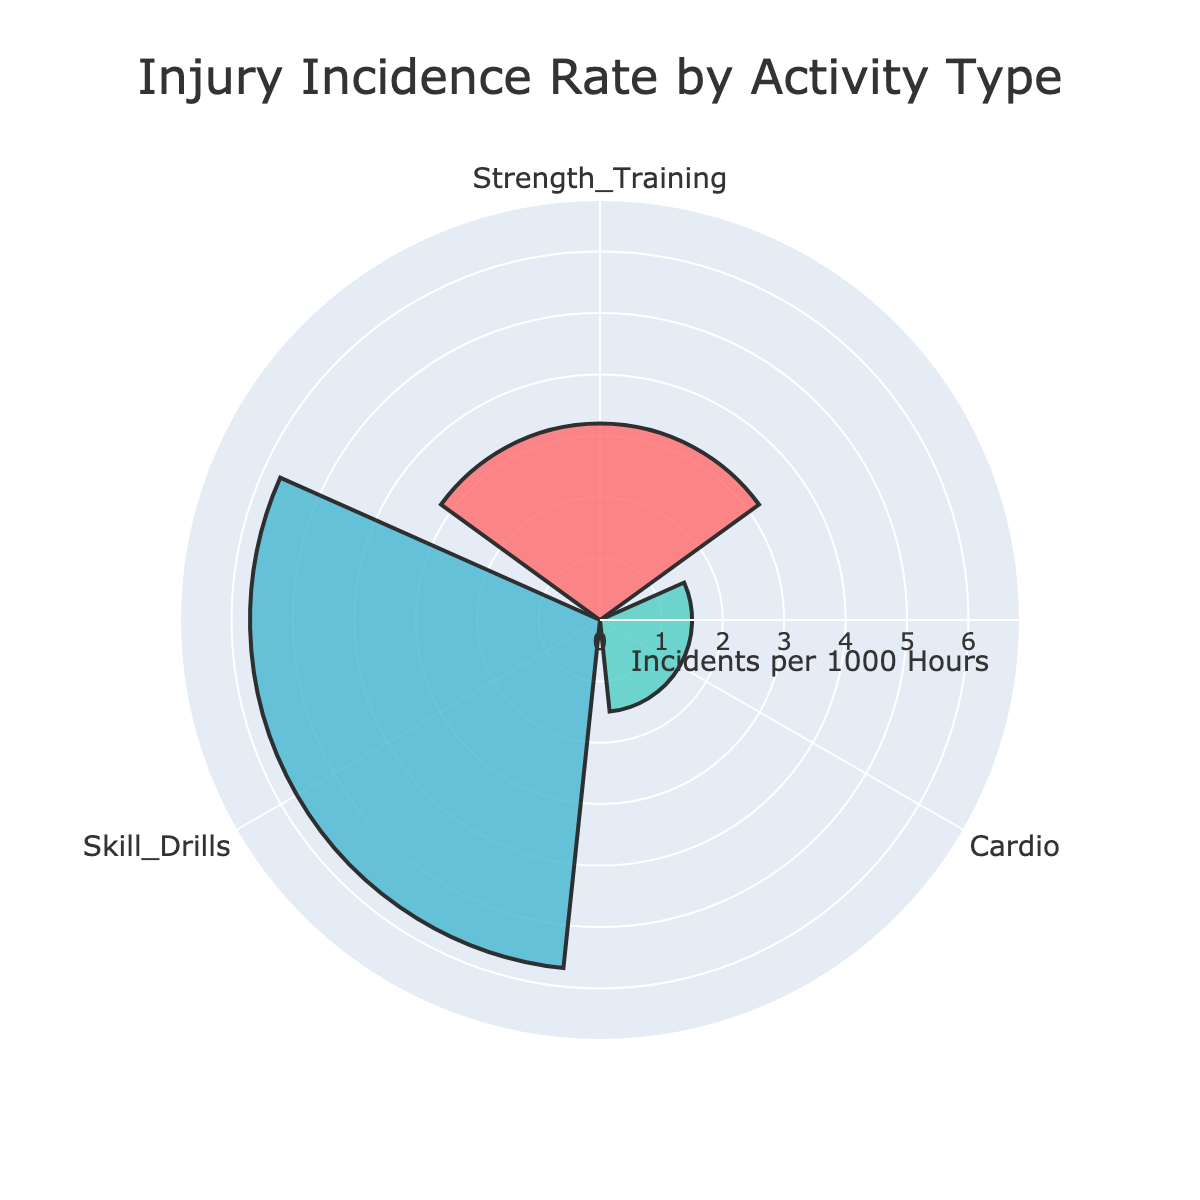what is the title of the figure? The title of the figure is shown prominently at the top and can be read as "Injury Incidence Rate by Activity Type".
Answer: Injury Incidence Rate by Activity Type How many activity types are displayed in the chart? The chart shows three distinct sections, each representing different activity types.
Answer: Three Which activity type has the highest injury incidence rate? The radial bar that extends the furthest from the center represents the highest injury rate, which corresponds to "Skill Drills" with a rate of 5.7 incidents per 1000 hours.
Answer: Skill Drills What is the injury incidence rate for Cardio? By locating the "Cardio" section in the chart and looking at its radial extent, you can see that the injury incidence rate is 1.5 incidents per 1000 hours.
Answer: 1.5 Which activity type has the lowest injury incidence rate? Among the three radial bars, the one for "Cardio" extends the least from the center, indicating the lowest injury rate of 1.5 incidents per 1000 hours.
Answer: Cardio What is the difference in injury incidence rates between Strength Training and Skill Drills? The Injury rate for Skill Drills is 5.7, and for Strength Training, it is 3.2. Subtracting these gives 5.7 - 3.2 = 2.5
Answer: 2.5 What is the average injury incidence rate across all the activity types? Add the injury rates for all three activities (3.2 + 1.5 + 5.7) = 10.4, and then divide by the number of activities, 10.4 / 3 = 3.47
Answer: 3.47 Are the injury incidence rates evenly distributed among the activities? Observing the length of each radial bar, it's clear they are different: 3.2, 1.5, and 5.7, indicating an uneven distribution of injury rates.
Answer: No What percentage of the total injury incidents is contributed by Strength Training? First, calculate the sum of all incidences, which is 3.2 + 1.5 + 5.7 = 10.4. Then, (3.2 / 10.4) * 100 = 30.77%
Answer: 30.77% Does any activity type have an injury incidence rate greater than twice that of Cardio? The injury incidence rate greater than twice Cardio (1.5 * 2 = 3) is "Skill Drills" with 5.7, which is greater than 3.
Answer: Yes 